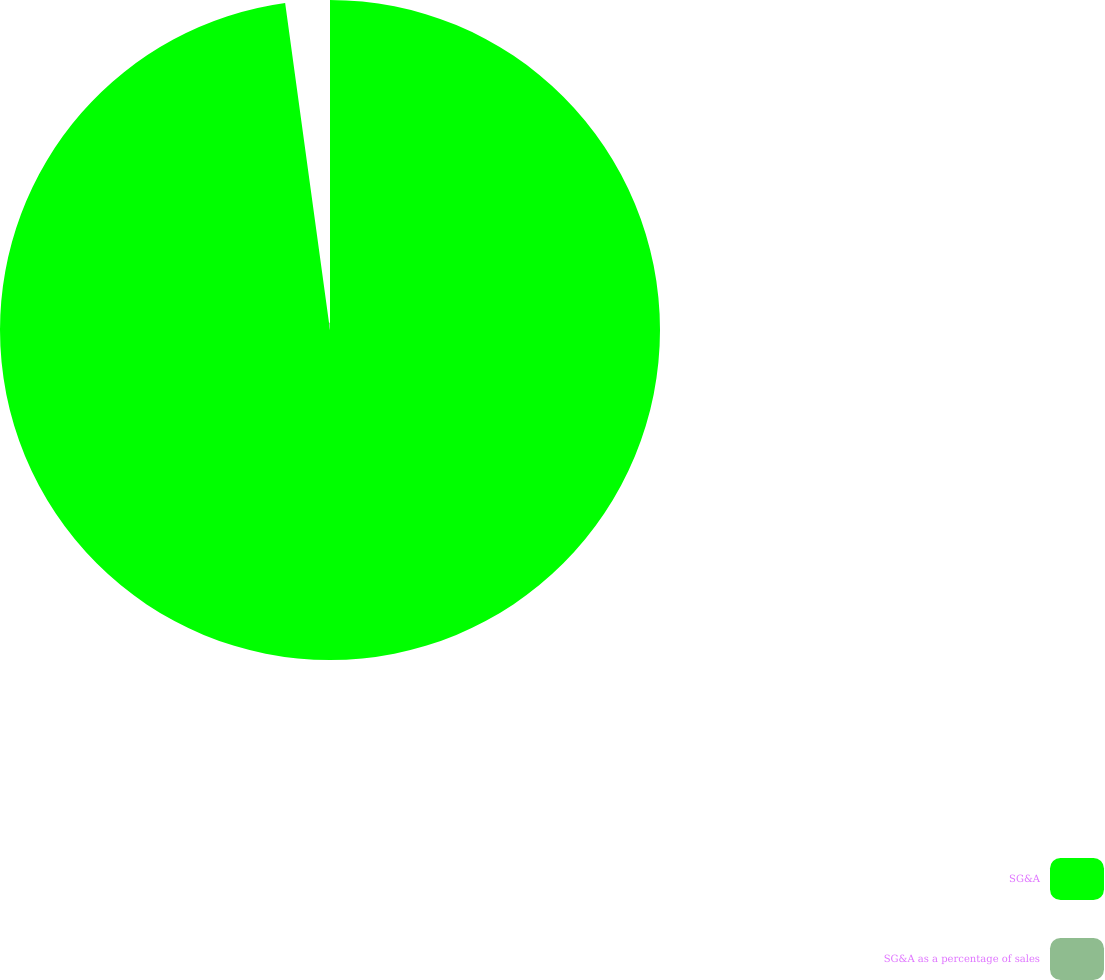Convert chart. <chart><loc_0><loc_0><loc_500><loc_500><pie_chart><fcel>SG&A<fcel>SG&A as a percentage of sales<nl><fcel>97.83%<fcel>2.17%<nl></chart> 